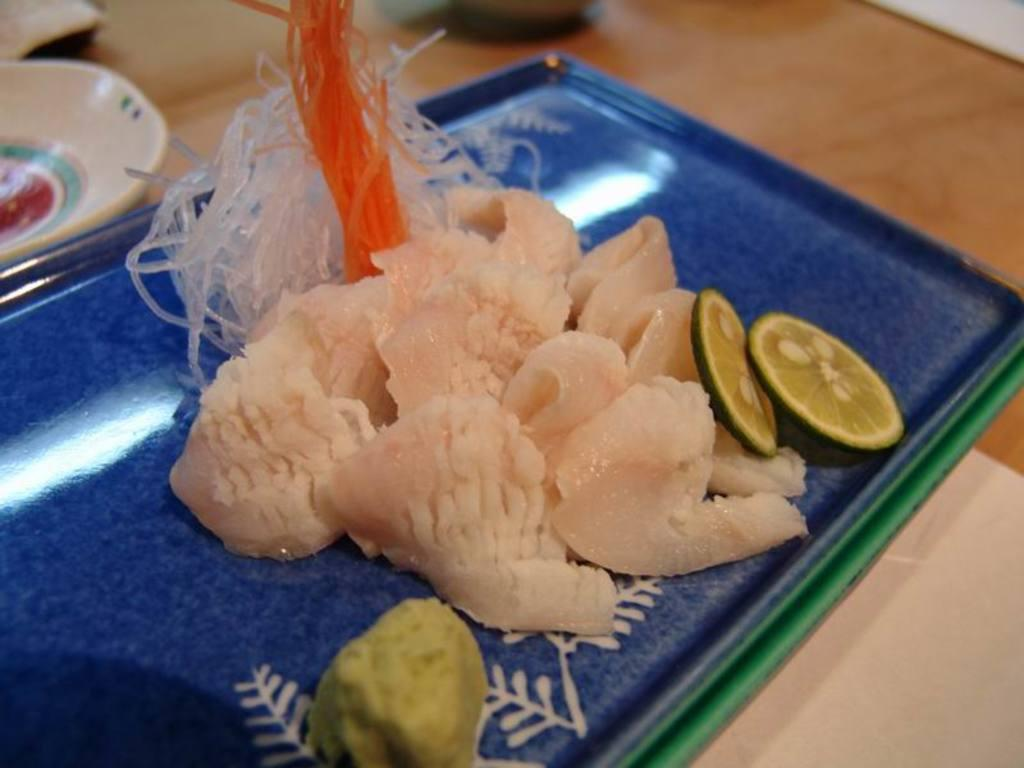What piece of furniture is present in the image? There is a table in the image. What is placed on the table? There is a plate on the table. What is on the plate? There is a food item in the plate. What else is on the table besides the plate? There are bowls beside the plate. Can you describe the behavior of the foot in the image? There is no foot present in the image. What type of mask is being worn by the person in the image? There is no person or mask present in the image. 